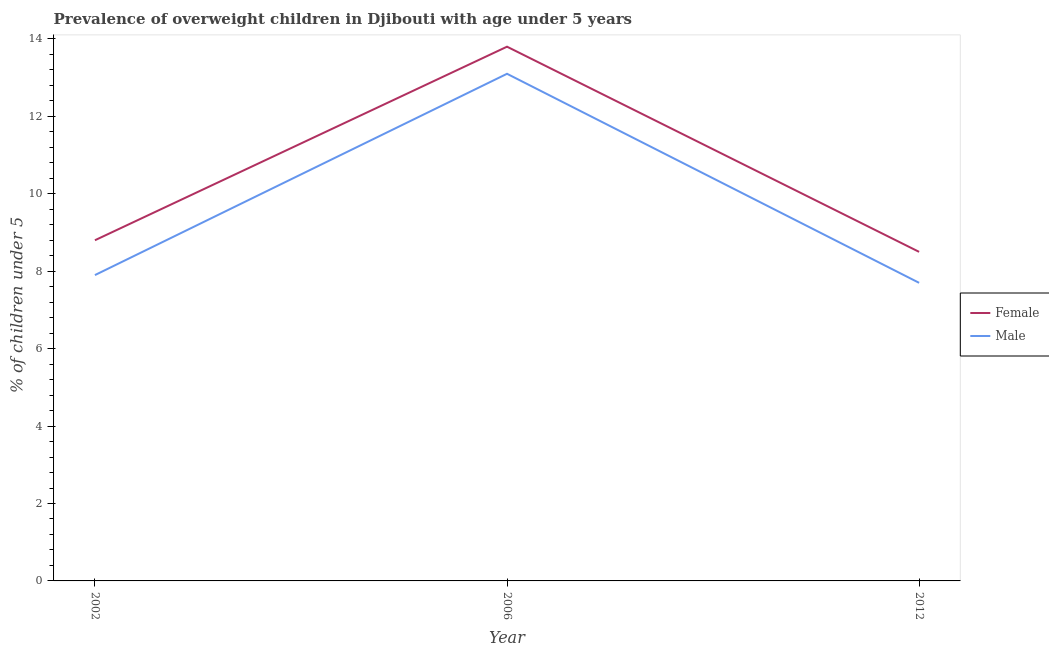Is the number of lines equal to the number of legend labels?
Make the answer very short. Yes. What is the percentage of obese male children in 2006?
Give a very brief answer. 13.1. Across all years, what is the maximum percentage of obese male children?
Offer a very short reply. 13.1. Across all years, what is the minimum percentage of obese male children?
Your response must be concise. 7.7. In which year was the percentage of obese male children minimum?
Offer a terse response. 2012. What is the total percentage of obese female children in the graph?
Offer a terse response. 31.1. What is the difference between the percentage of obese female children in 2002 and that in 2006?
Provide a short and direct response. -5. What is the difference between the percentage of obese female children in 2012 and the percentage of obese male children in 2002?
Your answer should be very brief. 0.6. What is the average percentage of obese male children per year?
Your answer should be very brief. 9.57. In the year 2002, what is the difference between the percentage of obese female children and percentage of obese male children?
Keep it short and to the point. 0.9. In how many years, is the percentage of obese female children greater than 2.8 %?
Keep it short and to the point. 3. What is the ratio of the percentage of obese male children in 2006 to that in 2012?
Provide a succinct answer. 1.7. Is the percentage of obese female children in 2006 less than that in 2012?
Your answer should be very brief. No. Is the difference between the percentage of obese female children in 2006 and 2012 greater than the difference between the percentage of obese male children in 2006 and 2012?
Offer a terse response. No. What is the difference between the highest and the second highest percentage of obese female children?
Keep it short and to the point. 5. What is the difference between the highest and the lowest percentage of obese female children?
Keep it short and to the point. 5.3. In how many years, is the percentage of obese female children greater than the average percentage of obese female children taken over all years?
Give a very brief answer. 1. Is the percentage of obese female children strictly greater than the percentage of obese male children over the years?
Your answer should be compact. Yes. Does the graph contain any zero values?
Your answer should be very brief. No. How many legend labels are there?
Keep it short and to the point. 2. How are the legend labels stacked?
Offer a very short reply. Vertical. What is the title of the graph?
Your response must be concise. Prevalence of overweight children in Djibouti with age under 5 years. What is the label or title of the X-axis?
Provide a succinct answer. Year. What is the label or title of the Y-axis?
Your response must be concise.  % of children under 5. What is the  % of children under 5 in Female in 2002?
Make the answer very short. 8.8. What is the  % of children under 5 in Male in 2002?
Your answer should be compact. 7.9. What is the  % of children under 5 in Female in 2006?
Provide a succinct answer. 13.8. What is the  % of children under 5 of Male in 2006?
Ensure brevity in your answer.  13.1. What is the  % of children under 5 of Female in 2012?
Offer a very short reply. 8.5. What is the  % of children under 5 of Male in 2012?
Ensure brevity in your answer.  7.7. Across all years, what is the maximum  % of children under 5 of Female?
Give a very brief answer. 13.8. Across all years, what is the maximum  % of children under 5 of Male?
Your response must be concise. 13.1. Across all years, what is the minimum  % of children under 5 in Male?
Provide a succinct answer. 7.7. What is the total  % of children under 5 of Female in the graph?
Provide a succinct answer. 31.1. What is the total  % of children under 5 in Male in the graph?
Offer a terse response. 28.7. What is the difference between the  % of children under 5 in Male in 2002 and that in 2006?
Provide a succinct answer. -5.2. What is the difference between the  % of children under 5 of Female in 2006 and that in 2012?
Your answer should be very brief. 5.3. What is the difference between the  % of children under 5 in Female in 2006 and the  % of children under 5 in Male in 2012?
Keep it short and to the point. 6.1. What is the average  % of children under 5 of Female per year?
Provide a short and direct response. 10.37. What is the average  % of children under 5 in Male per year?
Provide a short and direct response. 9.57. In the year 2002, what is the difference between the  % of children under 5 of Female and  % of children under 5 of Male?
Offer a very short reply. 0.9. In the year 2006, what is the difference between the  % of children under 5 in Female and  % of children under 5 in Male?
Provide a succinct answer. 0.7. What is the ratio of the  % of children under 5 in Female in 2002 to that in 2006?
Ensure brevity in your answer.  0.64. What is the ratio of the  % of children under 5 of Male in 2002 to that in 2006?
Give a very brief answer. 0.6. What is the ratio of the  % of children under 5 in Female in 2002 to that in 2012?
Provide a succinct answer. 1.04. What is the ratio of the  % of children under 5 of Female in 2006 to that in 2012?
Keep it short and to the point. 1.62. What is the ratio of the  % of children under 5 in Male in 2006 to that in 2012?
Your answer should be compact. 1.7. What is the difference between the highest and the lowest  % of children under 5 in Female?
Keep it short and to the point. 5.3. What is the difference between the highest and the lowest  % of children under 5 of Male?
Your answer should be very brief. 5.4. 